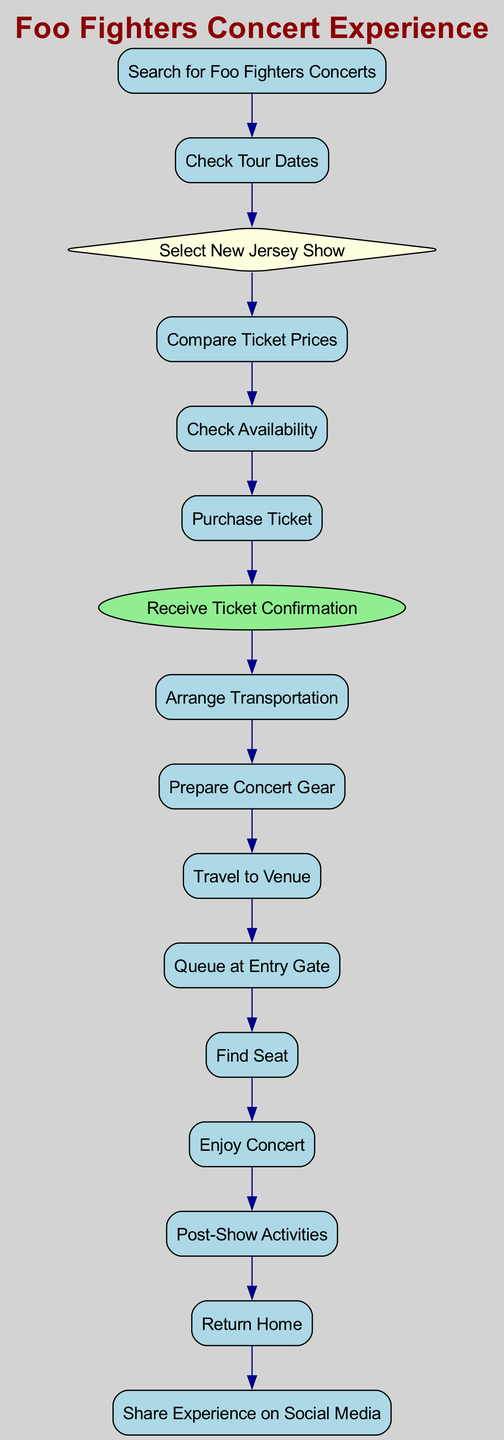What is the first action in the diagram? The diagram starts with the action node labeled "Search for Foo Fighters Concerts". This is the first step listed in the sequence of actions as seen from top to bottom.
Answer: Search for Foo Fighters Concerts How many actions are there in total? By counting the nodes labeled as "action" in the diagram, there are 13 action nodes present in total.
Answer: 13 What decision point occurs after checking tour dates? After the action "Check Tour Dates," the next step is a decision point labeled "Select New Jersey Show". It indicates the choice of location for the concert.
Answer: Select New Jersey Show What is the last action before returning home? The last action before "Return Home" is "Share Experience on Social Media". This indicates a step taken after the concert experience.
Answer: Share Experience on Social Media Which action follows the purchase of the ticket? Following the action "Purchase Ticket," the next action taken is "Receive Ticket Confirmation". This shows the sequence of actions after acquiring a concert ticket.
Answer: Receive Ticket Confirmation How many events are shown in the diagram? The diagram features one event, which is "Receive Ticket Confirmation". This is the only event node present.
Answer: 1 What is the flow of actions after deciding to select a New Jersey show? After deciding to select a New Jersey show, the flow continues to the actions "Compare Ticket Prices," "Check Availability," and finally leads to "Purchase Ticket." This shows the progression from decision to action.
Answer: Compare Ticket Prices, Check Availability, Purchase Ticket Identify the action that occurs immediately after enjoying the concert. Immediately after "Enjoy Concert," the next action is "Post-Show Activities", which implies activities following the concert.
Answer: Post-Show Activities What action takes place between receiving the ticket confirmation and arranging transportation? There are no actions occurring between "Receive Ticket Confirmation" and "Arrange Transportation"; these two actions follow in direct sequence in the diagram.
Answer: None 